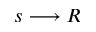<formula> <loc_0><loc_0><loc_500><loc_500>s \longrightarrow R</formula> 